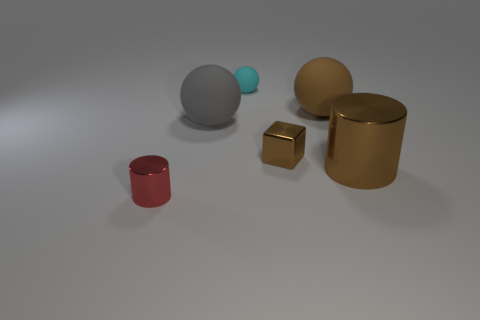Add 1 large purple metallic objects. How many objects exist? 7 Subtract all cylinders. How many objects are left? 4 Subtract 0 purple cylinders. How many objects are left? 6 Subtract all small brown metallic things. Subtract all small cubes. How many objects are left? 4 Add 2 cyan rubber objects. How many cyan rubber objects are left? 3 Add 6 cyan things. How many cyan things exist? 7 